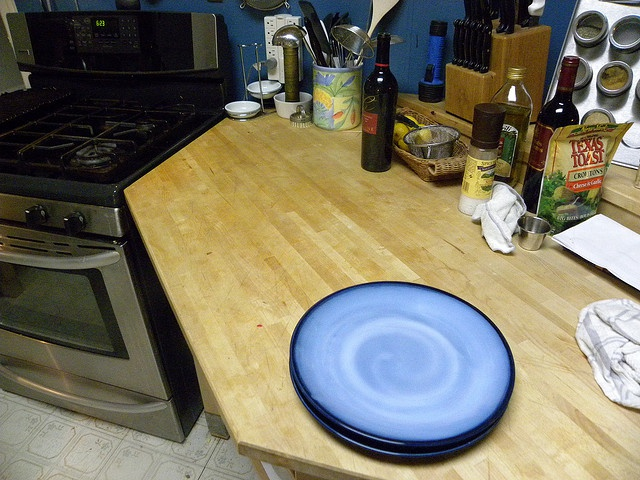Describe the objects in this image and their specific colors. I can see dining table in gray, tan, and black tones, oven in gray, black, and darkgreen tones, bottle in gray, black, maroon, olive, and brown tones, bottle in gray, black, maroon, and olive tones, and bottle in gray, black, and olive tones in this image. 